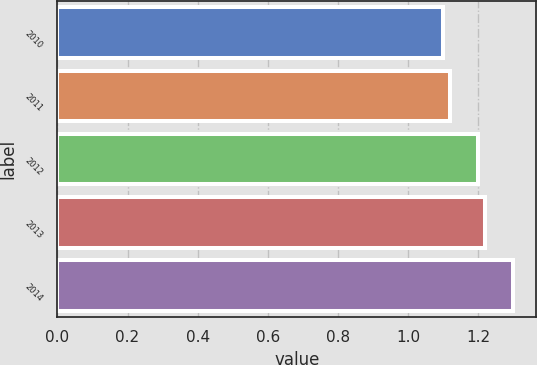<chart> <loc_0><loc_0><loc_500><loc_500><bar_chart><fcel>2010<fcel>2011<fcel>2012<fcel>2013<fcel>2014<nl><fcel>1.1<fcel>1.12<fcel>1.2<fcel>1.22<fcel>1.3<nl></chart> 